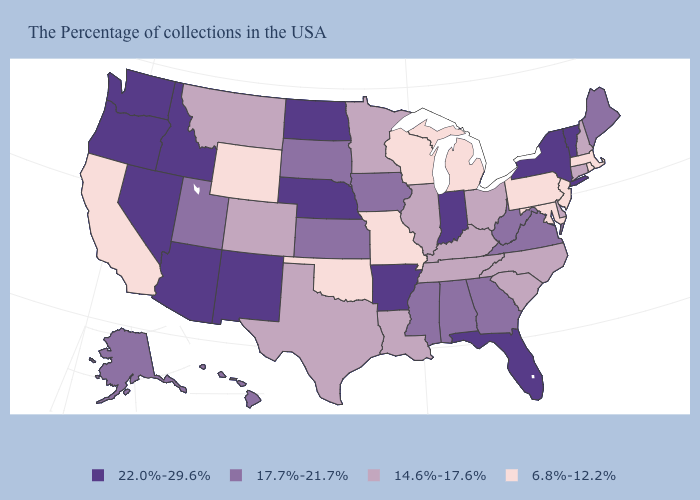Does Utah have the highest value in the USA?
Give a very brief answer. No. Which states have the highest value in the USA?
Short answer required. Vermont, New York, Florida, Indiana, Arkansas, Nebraska, North Dakota, New Mexico, Arizona, Idaho, Nevada, Washington, Oregon. Name the states that have a value in the range 14.6%-17.6%?
Quick response, please. New Hampshire, Connecticut, Delaware, North Carolina, South Carolina, Ohio, Kentucky, Tennessee, Illinois, Louisiana, Minnesota, Texas, Colorado, Montana. What is the highest value in states that border Ohio?
Quick response, please. 22.0%-29.6%. Which states have the lowest value in the USA?
Answer briefly. Massachusetts, Rhode Island, New Jersey, Maryland, Pennsylvania, Michigan, Wisconsin, Missouri, Oklahoma, Wyoming, California. Which states hav the highest value in the South?
Quick response, please. Florida, Arkansas. What is the value of Mississippi?
Be succinct. 17.7%-21.7%. Name the states that have a value in the range 17.7%-21.7%?
Write a very short answer. Maine, Virginia, West Virginia, Georgia, Alabama, Mississippi, Iowa, Kansas, South Dakota, Utah, Alaska, Hawaii. What is the value of Utah?
Keep it brief. 17.7%-21.7%. What is the lowest value in the USA?
Answer briefly. 6.8%-12.2%. Name the states that have a value in the range 6.8%-12.2%?
Short answer required. Massachusetts, Rhode Island, New Jersey, Maryland, Pennsylvania, Michigan, Wisconsin, Missouri, Oklahoma, Wyoming, California. Name the states that have a value in the range 22.0%-29.6%?
Keep it brief. Vermont, New York, Florida, Indiana, Arkansas, Nebraska, North Dakota, New Mexico, Arizona, Idaho, Nevada, Washington, Oregon. Among the states that border New York , does New Jersey have the lowest value?
Give a very brief answer. Yes. What is the value of Alaska?
Quick response, please. 17.7%-21.7%. Name the states that have a value in the range 14.6%-17.6%?
Quick response, please. New Hampshire, Connecticut, Delaware, North Carolina, South Carolina, Ohio, Kentucky, Tennessee, Illinois, Louisiana, Minnesota, Texas, Colorado, Montana. 